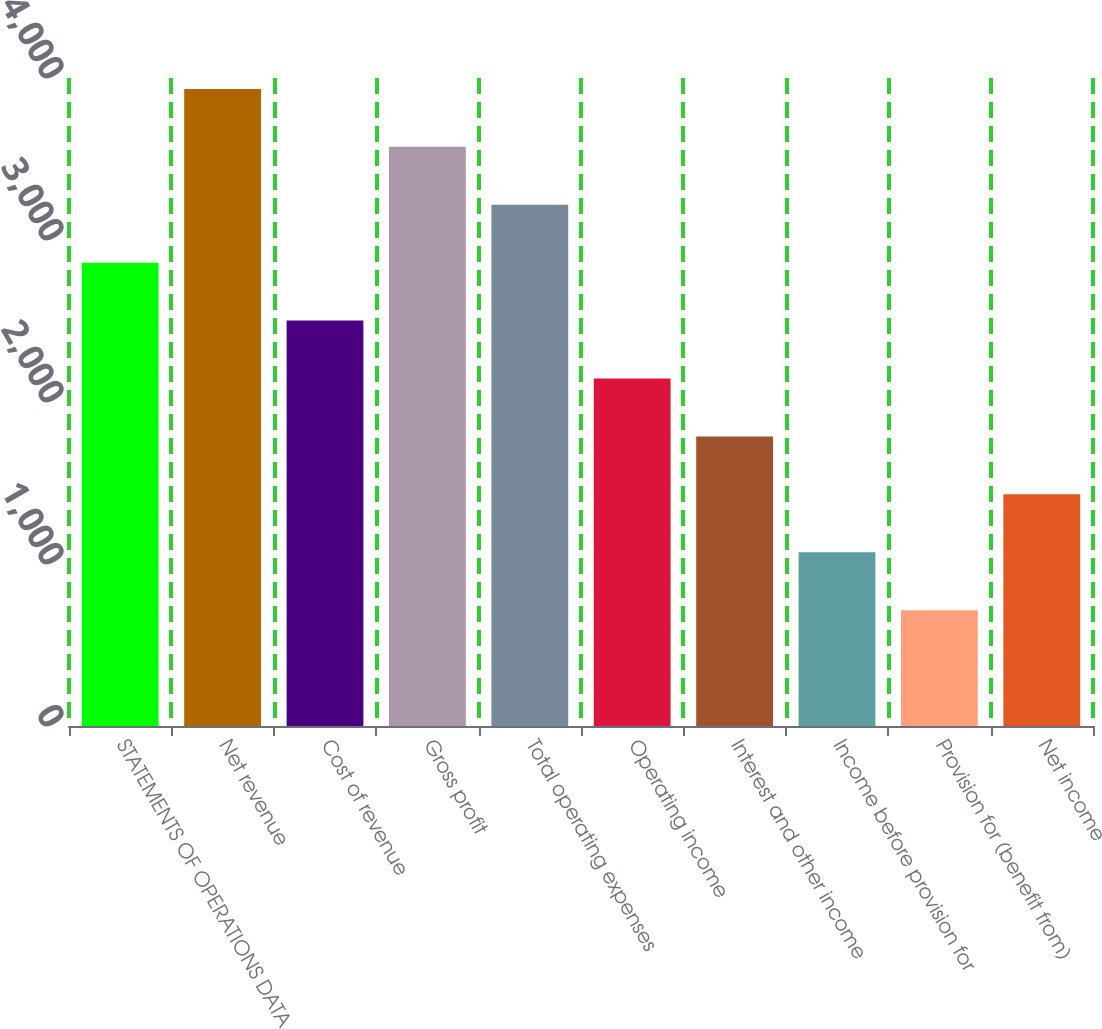Convert chart. <chart><loc_0><loc_0><loc_500><loc_500><bar_chart><fcel>STATEMENTS OF OPERATIONS DATA<fcel>Net revenue<fcel>Cost of revenue<fcel>Gross profit<fcel>Total operating expenses<fcel>Operating income<fcel>Interest and other income<fcel>Income before provision for<fcel>Provision for (benefit from)<fcel>Net income<nl><fcel>2860.03<fcel>3932.53<fcel>2502.53<fcel>3575.03<fcel>3217.53<fcel>2145.03<fcel>1787.53<fcel>1072.53<fcel>715.03<fcel>1430.03<nl></chart> 